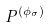<formula> <loc_0><loc_0><loc_500><loc_500>P ^ { ( \phi _ { \sigma } ) }</formula> 